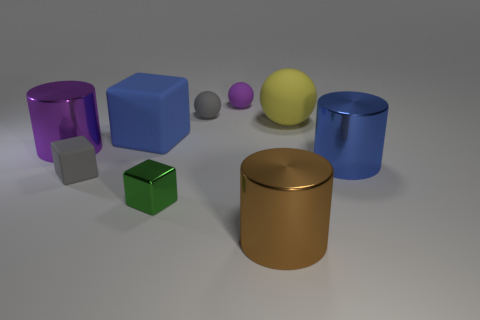Add 1 red things. How many objects exist? 10 Subtract all cubes. How many objects are left? 6 Subtract all purple metal cylinders. Subtract all gray spheres. How many objects are left? 7 Add 9 big blue cubes. How many big blue cubes are left? 10 Add 8 blue cubes. How many blue cubes exist? 9 Subtract 1 gray cubes. How many objects are left? 8 